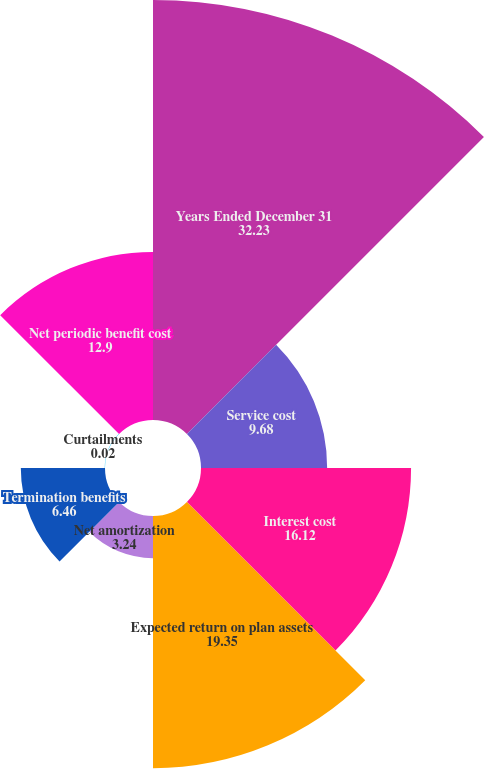Convert chart to OTSL. <chart><loc_0><loc_0><loc_500><loc_500><pie_chart><fcel>Years Ended December 31<fcel>Service cost<fcel>Interest cost<fcel>Expected return on plan assets<fcel>Net amortization<fcel>Termination benefits<fcel>Curtailments<fcel>Net periodic benefit cost<nl><fcel>32.23%<fcel>9.68%<fcel>16.12%<fcel>19.35%<fcel>3.24%<fcel>6.46%<fcel>0.02%<fcel>12.9%<nl></chart> 